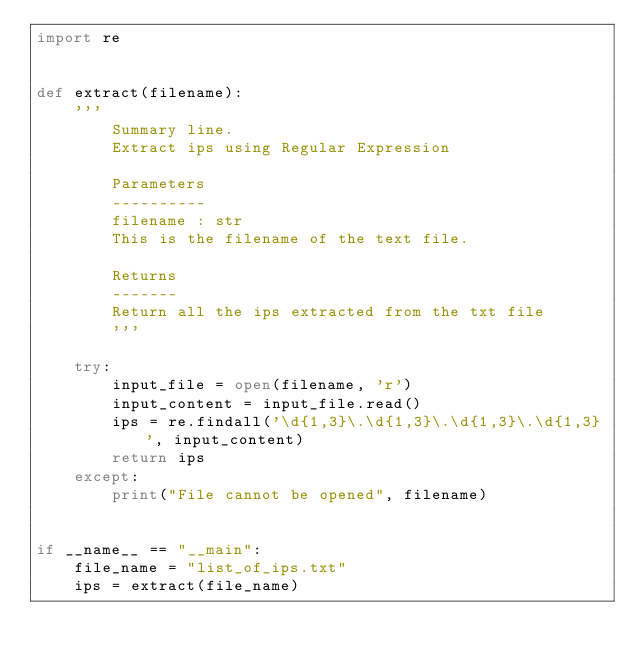<code> <loc_0><loc_0><loc_500><loc_500><_Python_>import re


def extract(filename):
    '''
        Summary line.
        Extract ips using Regular Expression

        Parameters
        ----------
        filename : str
        This is the filename of the text file.

        Returns
        -------
        Return all the ips extracted from the txt file
        '''

    try:
        input_file = open(filename, 'r')
        input_content = input_file.read()
        ips = re.findall('\d{1,3}\.\d{1,3}\.\d{1,3}\.\d{1,3}', input_content)
        return ips
    except:
        print("File cannot be opened", filename)


if __name__ == "__main":
    file_name = "list_of_ips.txt"
    ips = extract(file_name)
</code> 